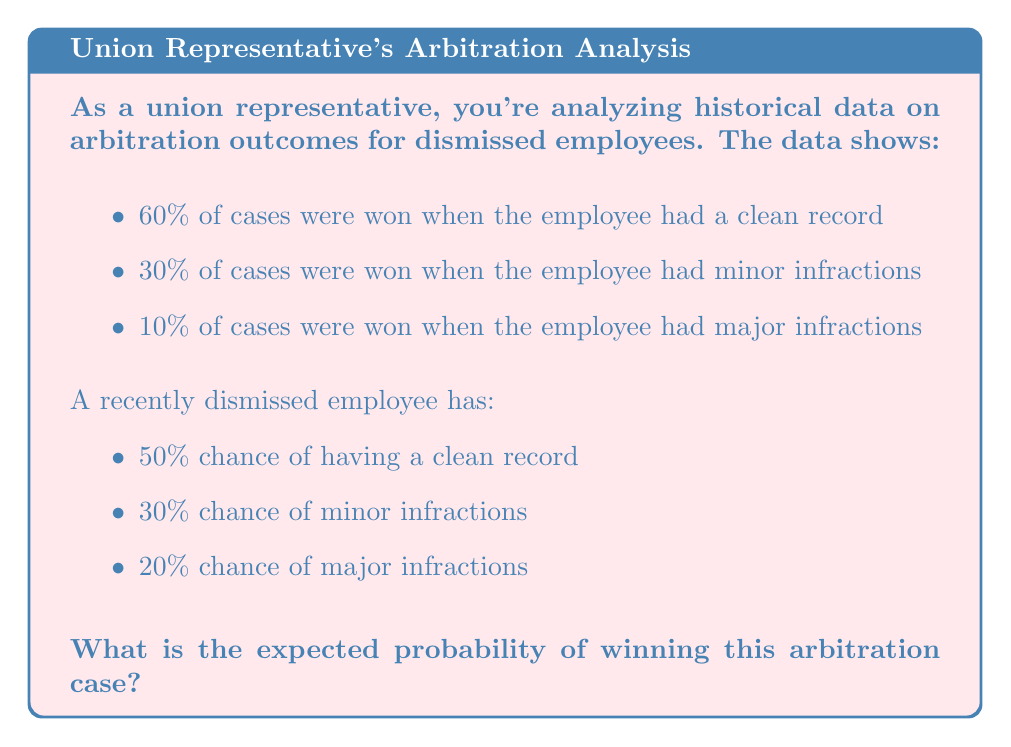Solve this math problem. To solve this problem, we'll use the law of total probability and calculate the expected value.

Step 1: Define events
Let W = winning the arbitration
Let C = clean record
Let M = minor infractions
Let J = major infractions

Step 2: Given probabilities
P(W|C) = 0.60 (probability of winning given clean record)
P(W|M) = 0.30 (probability of winning given minor infractions)
P(W|J) = 0.10 (probability of winning given major infractions)

P(C) = 0.50 (probability of clean record)
P(M) = 0.30 (probability of minor infractions)
P(J) = 0.20 (probability of major infractions)

Step 3: Apply the law of total probability
$$P(W) = P(W|C) \cdot P(C) + P(W|M) \cdot P(M) + P(W|J) \cdot P(J)$$

Step 4: Substitute the values
$$P(W) = 0.60 \cdot 0.50 + 0.30 \cdot 0.30 + 0.10 \cdot 0.20$$

Step 5: Calculate
$$P(W) = 0.30 + 0.09 + 0.02 = 0.41$$

Therefore, the expected probability of winning this arbitration case is 0.41 or 41%.
Answer: 0.41 